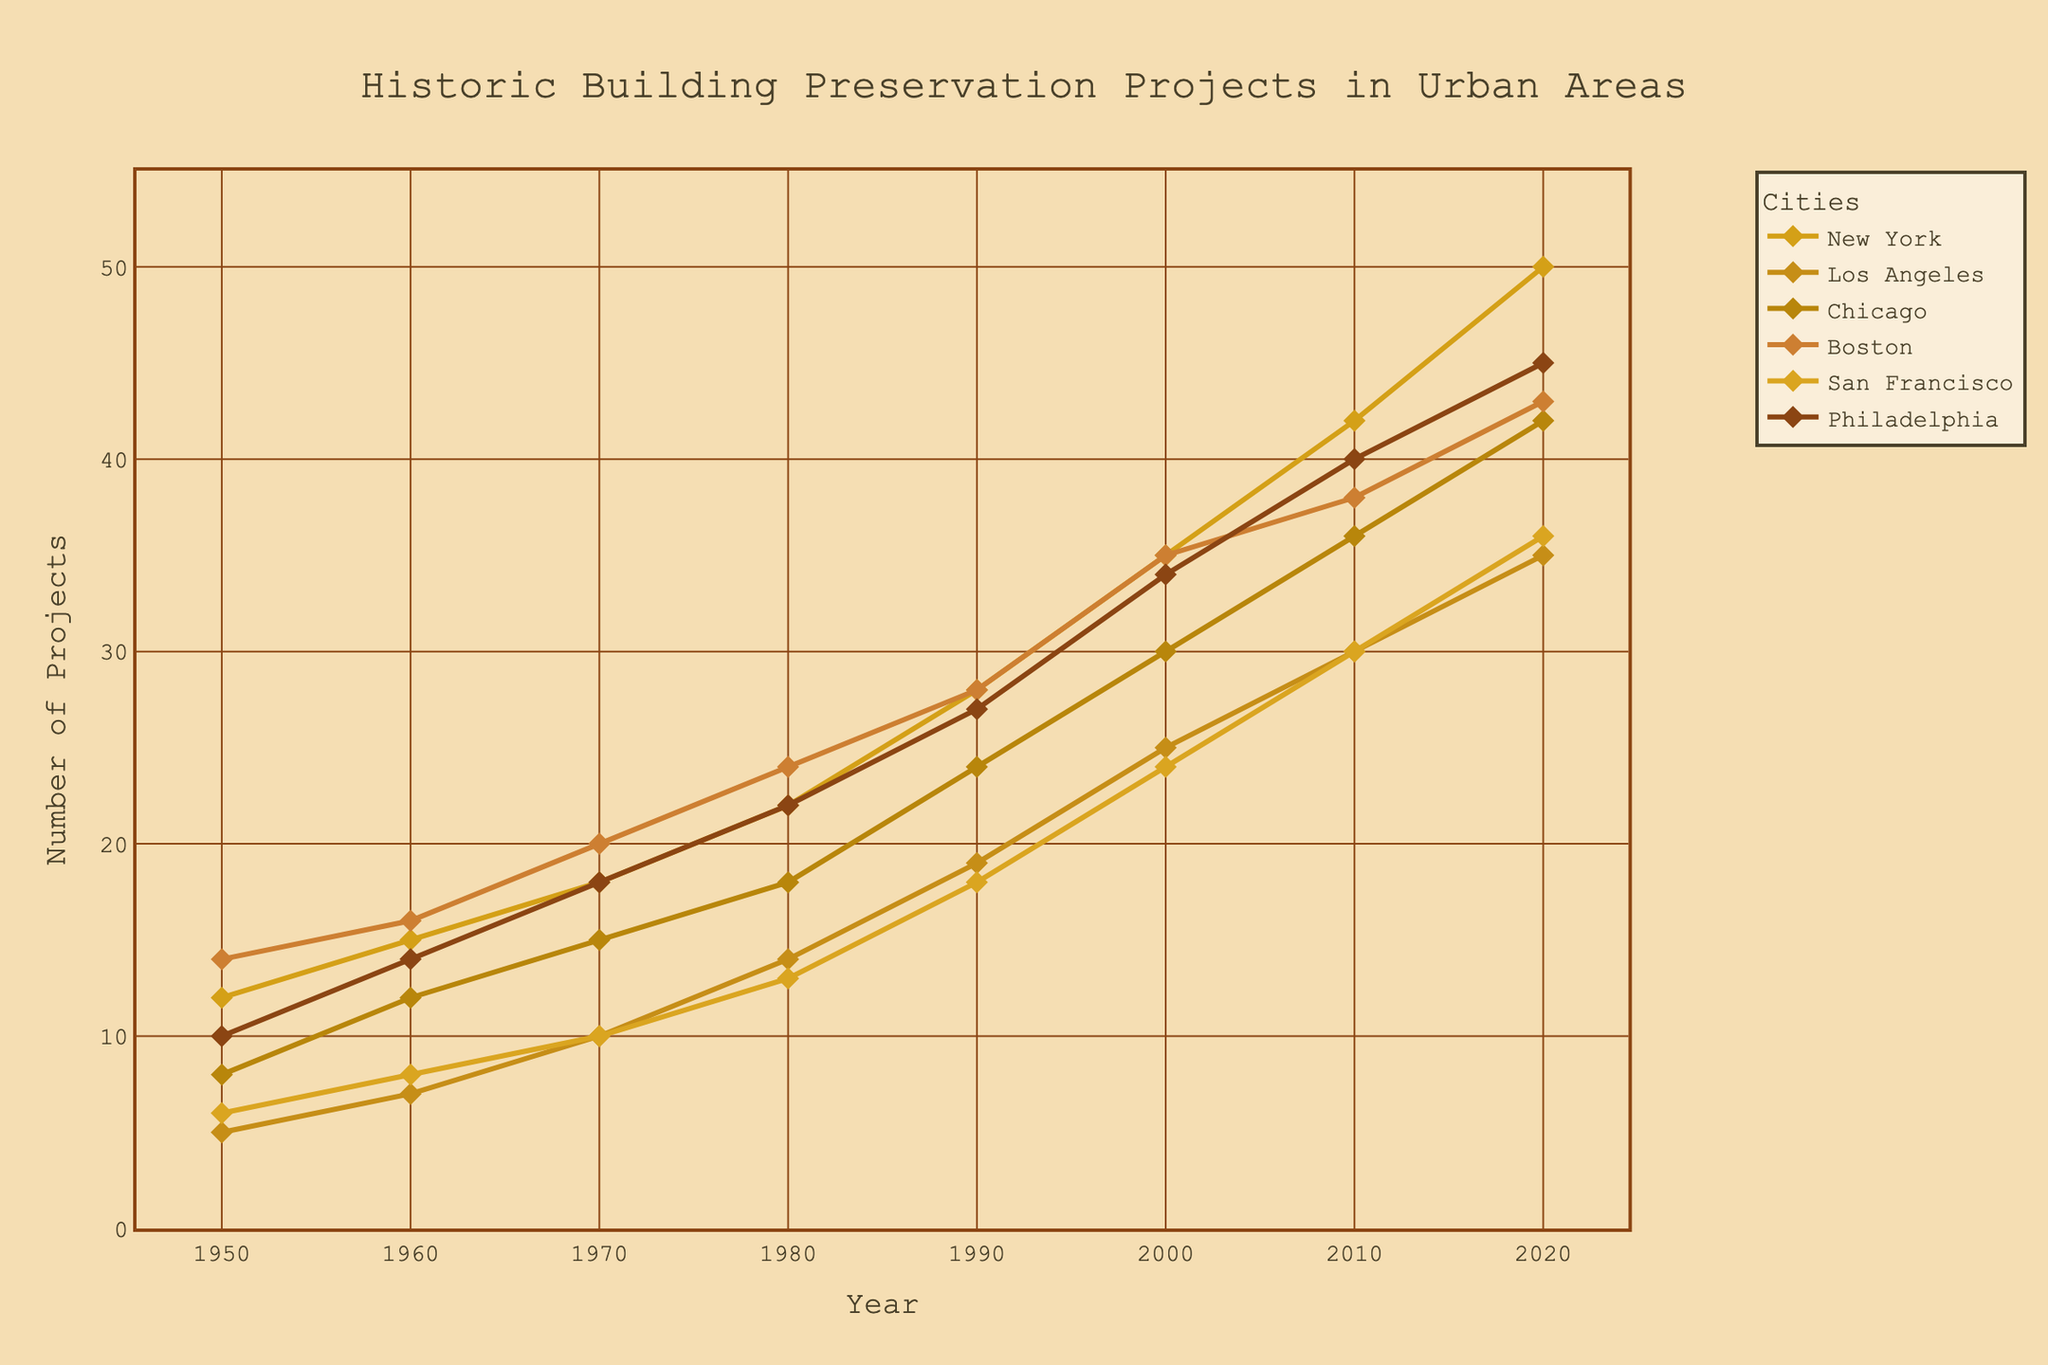What is the title of the figure? The title of the figure is found at the top and it describes the overall content of the figure. From the given figure, the title is centered and clearly states the theme in a nostalgic font and color.
Answer: Historic Building Preservation Projects in Urban Areas Which city had the highest number of projects in 2020? To find this, look at the endpoints of the lines in the figure corresponding to the year 2020 and compare their heights. The city with the highest endpoint is the one with the highest number of projects in 2020.
Answer: New York What was the number of projects in San Francisco in 1980? Locate the data point for San Francisco on the chart for the year 1980 and note its value on the y-axis.
Answer: 13 By how much did the number of projects in Boston increase from 1950 to 2020? Find the values for Boston in 1950 and 2020, then subtract the 1950 value from the 2020 value to get the increase. For Boston, it was 14 in 1950 and 43 in 2020, so the increase is 43 - 14.
Answer: 29 How many projects were there in Philadelphia in 1960 and how does it compare to 2000? Look at the values for Philadelphia in both 1960 and 2000 and compare them directly.
Answer: 14 in 1960, increased to 34 in 2000 Which city had the smallest increase in the number of projects from 1950 to 2020? Calculate the increase for each city by subtracting the 1950 value from the 2020 value and then compare the resulting increases to find the smallest one.
Answer: Los Angeles Did any city have a decrease in the number of projects in any of the decades shown? Visually inspect the lines for any downward slopes between decades. If no line slopes downward, then there were no decreases.
Answer: No Calculate the total number of projects across all cities in 1990 Sum the values for all the cities in the year 1990. The cities' values are New York 28, Los Angeles 19, Chicago 24, Boston 28, San Francisco 18, and Philadelphia 27. So, the total is 28 + 19 + 24 + 28 + 18 + 27.
Answer: 144 Compare the trends in preservation projects between San Francisco and Philadelphia. Look at the lines representing both cities from 1950 to 2020. Note their starting points, ending points, and how they progress over time to compare their trends.
Answer: Both increased but San Francisco saw smaller increases over time compared to Philadelphia 